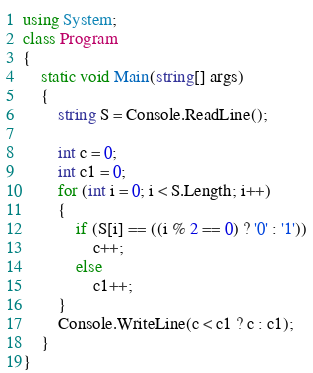<code> <loc_0><loc_0><loc_500><loc_500><_C#_>using System;
class Program
{
    static void Main(string[] args)
    {
        string S = Console.ReadLine();

        int c = 0;
        int c1 = 0;
        for (int i = 0; i < S.Length; i++)
        {
            if (S[i] == ((i % 2 == 0) ? '0' : '1'))
                c++;
            else
                c1++;
        }
        Console.WriteLine(c < c1 ? c : c1);
    }
}
</code> 